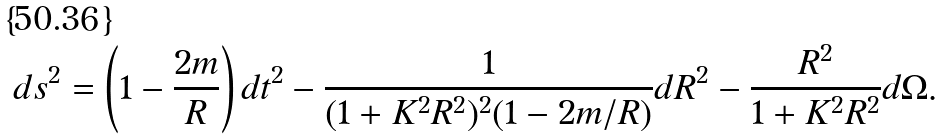Convert formula to latex. <formula><loc_0><loc_0><loc_500><loc_500>d s ^ { 2 } = \left ( 1 - \frac { 2 m } { R } \right ) d t ^ { 2 } - \frac { 1 } { ( 1 + K ^ { 2 } R ^ { 2 } ) ^ { 2 } ( 1 - 2 m / R ) } d R ^ { 2 } - \frac { R ^ { 2 } } { 1 + K ^ { 2 } R ^ { 2 } } d \Omega .</formula> 